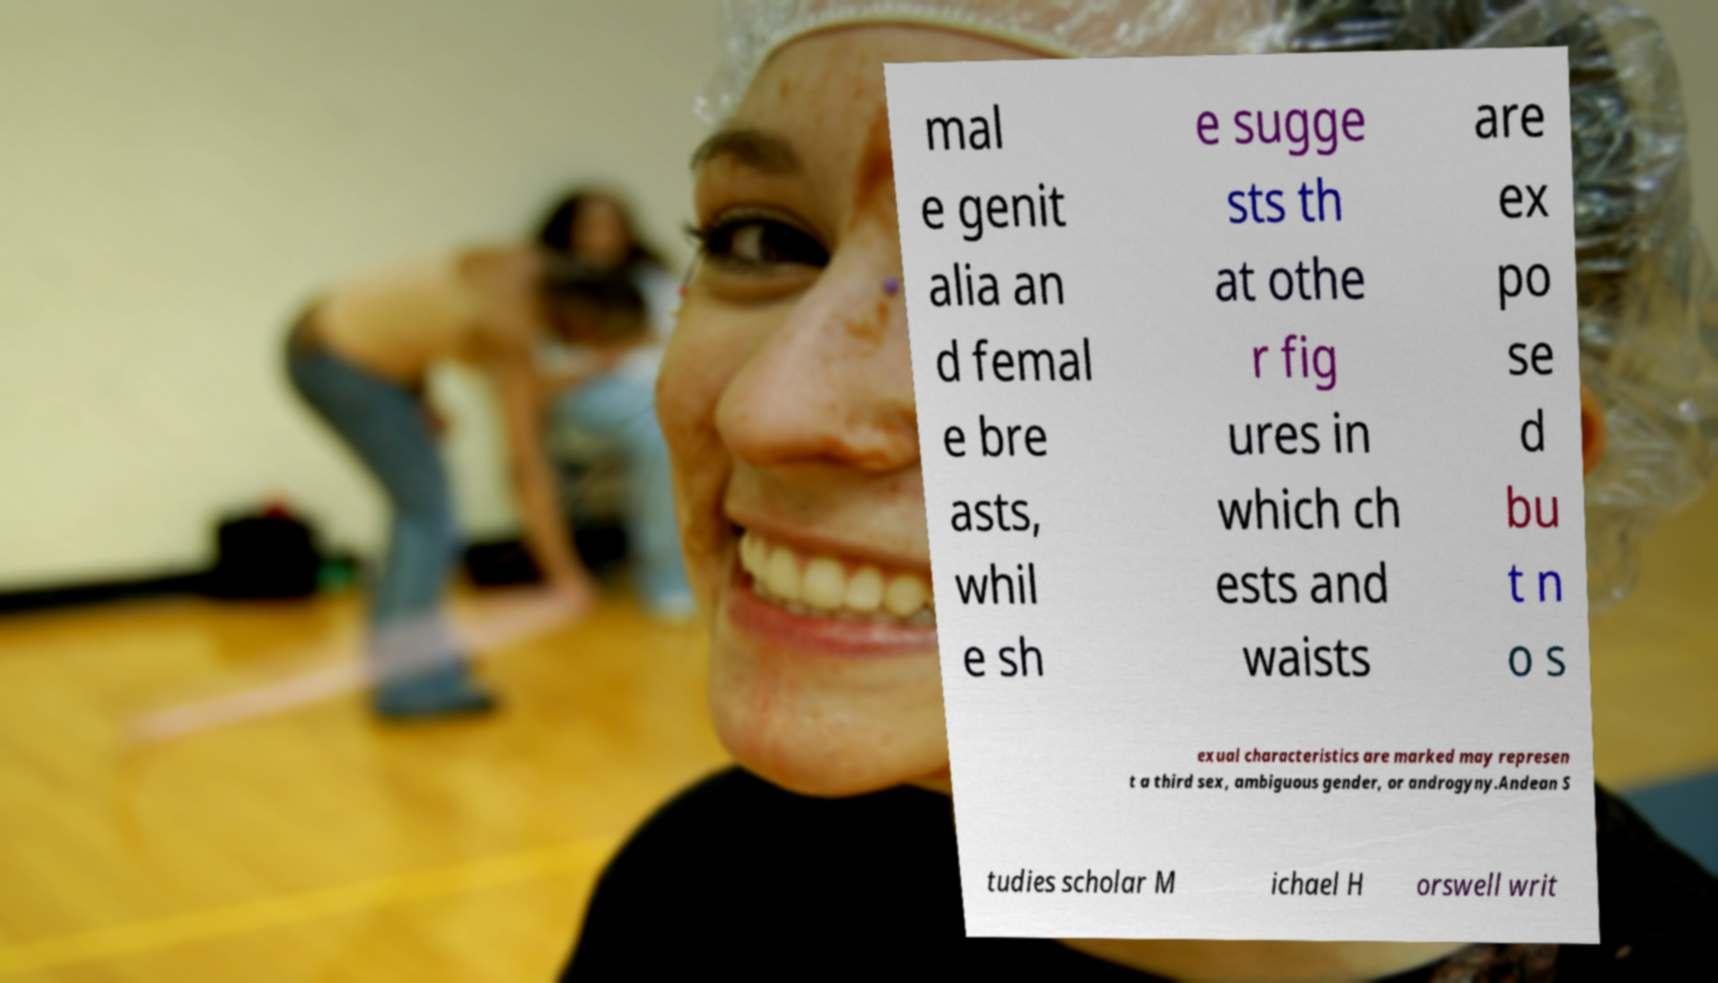For documentation purposes, I need the text within this image transcribed. Could you provide that? mal e genit alia an d femal e bre asts, whil e sh e sugge sts th at othe r fig ures in which ch ests and waists are ex po se d bu t n o s exual characteristics are marked may represen t a third sex, ambiguous gender, or androgyny.Andean S tudies scholar M ichael H orswell writ 